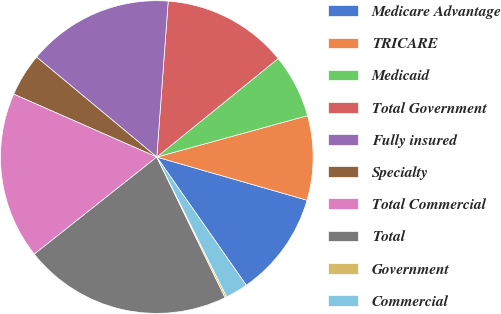Convert chart to OTSL. <chart><loc_0><loc_0><loc_500><loc_500><pie_chart><fcel>Medicare Advantage<fcel>TRICARE<fcel>Medicaid<fcel>Total Government<fcel>Fully insured<fcel>Specialty<fcel>Total Commercial<fcel>Total<fcel>Government<fcel>Commercial<nl><fcel>10.85%<fcel>8.72%<fcel>6.58%<fcel>12.99%<fcel>15.12%<fcel>4.45%<fcel>17.26%<fcel>21.53%<fcel>0.18%<fcel>2.32%<nl></chart> 